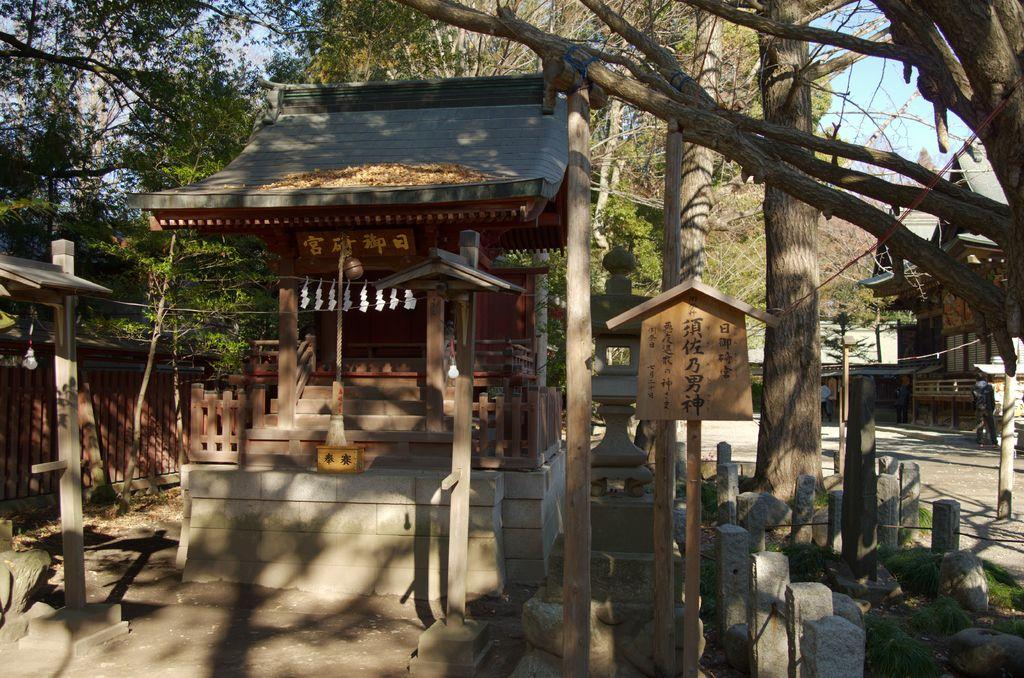What type of structures can be seen in the image? There are poles, a fence, and houses in the image. What other objects are present in the image? There are wooden sticks and trees in the image. What can be seen in the background of the image? The sky is visible in the background of the image. What type of ear is visible on the wooden sticks in the image? There are no ears present in the image, as the wooden sticks are not associated with ears. What type of underwear can be seen hanging on the poles in the image? There is no underwear present in the image; the poles are not associated with underwear. 